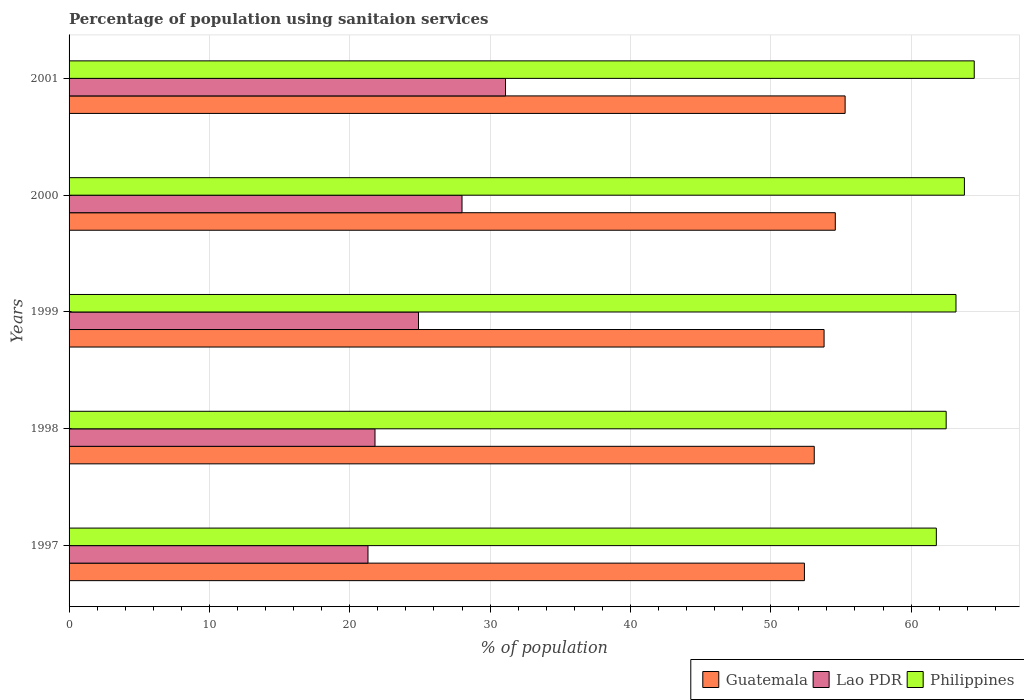How many different coloured bars are there?
Provide a short and direct response. 3. How many groups of bars are there?
Your answer should be very brief. 5. Are the number of bars on each tick of the Y-axis equal?
Provide a short and direct response. Yes. How many bars are there on the 1st tick from the top?
Make the answer very short. 3. How many bars are there on the 5th tick from the bottom?
Provide a succinct answer. 3. What is the percentage of population using sanitaion services in Guatemala in 2000?
Make the answer very short. 54.6. Across all years, what is the maximum percentage of population using sanitaion services in Philippines?
Your response must be concise. 64.5. Across all years, what is the minimum percentage of population using sanitaion services in Guatemala?
Ensure brevity in your answer.  52.4. In which year was the percentage of population using sanitaion services in Guatemala minimum?
Make the answer very short. 1997. What is the total percentage of population using sanitaion services in Lao PDR in the graph?
Give a very brief answer. 127.1. What is the difference between the percentage of population using sanitaion services in Lao PDR in 1999 and that in 2000?
Ensure brevity in your answer.  -3.1. What is the average percentage of population using sanitaion services in Guatemala per year?
Provide a succinct answer. 53.84. In the year 2001, what is the difference between the percentage of population using sanitaion services in Guatemala and percentage of population using sanitaion services in Lao PDR?
Your answer should be very brief. 24.2. What is the ratio of the percentage of population using sanitaion services in Philippines in 1997 to that in 2000?
Offer a terse response. 0.97. Is the difference between the percentage of population using sanitaion services in Guatemala in 1998 and 1999 greater than the difference between the percentage of population using sanitaion services in Lao PDR in 1998 and 1999?
Give a very brief answer. Yes. What is the difference between the highest and the second highest percentage of population using sanitaion services in Guatemala?
Provide a short and direct response. 0.7. What is the difference between the highest and the lowest percentage of population using sanitaion services in Lao PDR?
Your answer should be compact. 9.8. In how many years, is the percentage of population using sanitaion services in Philippines greater than the average percentage of population using sanitaion services in Philippines taken over all years?
Offer a terse response. 3. What does the 3rd bar from the top in 2001 represents?
Provide a short and direct response. Guatemala. What does the 2nd bar from the bottom in 2000 represents?
Offer a very short reply. Lao PDR. Is it the case that in every year, the sum of the percentage of population using sanitaion services in Guatemala and percentage of population using sanitaion services in Philippines is greater than the percentage of population using sanitaion services in Lao PDR?
Offer a terse response. Yes. Are the values on the major ticks of X-axis written in scientific E-notation?
Your answer should be compact. No. Does the graph contain grids?
Your answer should be very brief. Yes. How are the legend labels stacked?
Offer a terse response. Horizontal. What is the title of the graph?
Your answer should be very brief. Percentage of population using sanitaion services. What is the label or title of the X-axis?
Keep it short and to the point. % of population. What is the label or title of the Y-axis?
Make the answer very short. Years. What is the % of population of Guatemala in 1997?
Ensure brevity in your answer.  52.4. What is the % of population of Lao PDR in 1997?
Your answer should be compact. 21.3. What is the % of population of Philippines in 1997?
Your answer should be compact. 61.8. What is the % of population in Guatemala in 1998?
Offer a terse response. 53.1. What is the % of population in Lao PDR in 1998?
Your answer should be compact. 21.8. What is the % of population of Philippines in 1998?
Your answer should be very brief. 62.5. What is the % of population of Guatemala in 1999?
Provide a short and direct response. 53.8. What is the % of population of Lao PDR in 1999?
Your answer should be compact. 24.9. What is the % of population of Philippines in 1999?
Keep it short and to the point. 63.2. What is the % of population of Guatemala in 2000?
Provide a succinct answer. 54.6. What is the % of population of Lao PDR in 2000?
Offer a terse response. 28. What is the % of population of Philippines in 2000?
Offer a very short reply. 63.8. What is the % of population of Guatemala in 2001?
Your answer should be very brief. 55.3. What is the % of population of Lao PDR in 2001?
Provide a short and direct response. 31.1. What is the % of population in Philippines in 2001?
Ensure brevity in your answer.  64.5. Across all years, what is the maximum % of population of Guatemala?
Provide a succinct answer. 55.3. Across all years, what is the maximum % of population in Lao PDR?
Give a very brief answer. 31.1. Across all years, what is the maximum % of population of Philippines?
Ensure brevity in your answer.  64.5. Across all years, what is the minimum % of population in Guatemala?
Provide a succinct answer. 52.4. Across all years, what is the minimum % of population in Lao PDR?
Ensure brevity in your answer.  21.3. Across all years, what is the minimum % of population in Philippines?
Make the answer very short. 61.8. What is the total % of population of Guatemala in the graph?
Provide a succinct answer. 269.2. What is the total % of population in Lao PDR in the graph?
Offer a terse response. 127.1. What is the total % of population in Philippines in the graph?
Your answer should be compact. 315.8. What is the difference between the % of population of Lao PDR in 1997 and that in 1998?
Provide a succinct answer. -0.5. What is the difference between the % of population in Guatemala in 1997 and that in 1999?
Make the answer very short. -1.4. What is the difference between the % of population in Lao PDR in 1997 and that in 1999?
Give a very brief answer. -3.6. What is the difference between the % of population in Guatemala in 1997 and that in 2000?
Give a very brief answer. -2.2. What is the difference between the % of population of Lao PDR in 1997 and that in 2000?
Your response must be concise. -6.7. What is the difference between the % of population in Guatemala in 1997 and that in 2001?
Your response must be concise. -2.9. What is the difference between the % of population in Lao PDR in 1997 and that in 2001?
Provide a succinct answer. -9.8. What is the difference between the % of population in Philippines in 1997 and that in 2001?
Ensure brevity in your answer.  -2.7. What is the difference between the % of population of Lao PDR in 1998 and that in 1999?
Keep it short and to the point. -3.1. What is the difference between the % of population of Philippines in 1998 and that in 1999?
Your response must be concise. -0.7. What is the difference between the % of population in Guatemala in 1998 and that in 2000?
Your answer should be compact. -1.5. What is the difference between the % of population in Guatemala in 1998 and that in 2001?
Your answer should be compact. -2.2. What is the difference between the % of population of Lao PDR in 1998 and that in 2001?
Your answer should be very brief. -9.3. What is the difference between the % of population of Philippines in 1999 and that in 2001?
Your response must be concise. -1.3. What is the difference between the % of population of Guatemala in 2000 and that in 2001?
Your answer should be compact. -0.7. What is the difference between the % of population in Lao PDR in 2000 and that in 2001?
Ensure brevity in your answer.  -3.1. What is the difference between the % of population in Philippines in 2000 and that in 2001?
Ensure brevity in your answer.  -0.7. What is the difference between the % of population in Guatemala in 1997 and the % of population in Lao PDR in 1998?
Offer a terse response. 30.6. What is the difference between the % of population of Lao PDR in 1997 and the % of population of Philippines in 1998?
Keep it short and to the point. -41.2. What is the difference between the % of population in Guatemala in 1997 and the % of population in Lao PDR in 1999?
Your answer should be compact. 27.5. What is the difference between the % of population of Lao PDR in 1997 and the % of population of Philippines in 1999?
Give a very brief answer. -41.9. What is the difference between the % of population in Guatemala in 1997 and the % of population in Lao PDR in 2000?
Make the answer very short. 24.4. What is the difference between the % of population of Lao PDR in 1997 and the % of population of Philippines in 2000?
Make the answer very short. -42.5. What is the difference between the % of population of Guatemala in 1997 and the % of population of Lao PDR in 2001?
Provide a short and direct response. 21.3. What is the difference between the % of population of Lao PDR in 1997 and the % of population of Philippines in 2001?
Provide a short and direct response. -43.2. What is the difference between the % of population in Guatemala in 1998 and the % of population in Lao PDR in 1999?
Give a very brief answer. 28.2. What is the difference between the % of population in Guatemala in 1998 and the % of population in Philippines in 1999?
Your answer should be compact. -10.1. What is the difference between the % of population in Lao PDR in 1998 and the % of population in Philippines in 1999?
Ensure brevity in your answer.  -41.4. What is the difference between the % of population in Guatemala in 1998 and the % of population in Lao PDR in 2000?
Provide a succinct answer. 25.1. What is the difference between the % of population of Guatemala in 1998 and the % of population of Philippines in 2000?
Offer a very short reply. -10.7. What is the difference between the % of population in Lao PDR in 1998 and the % of population in Philippines in 2000?
Your response must be concise. -42. What is the difference between the % of population in Lao PDR in 1998 and the % of population in Philippines in 2001?
Keep it short and to the point. -42.7. What is the difference between the % of population in Guatemala in 1999 and the % of population in Lao PDR in 2000?
Offer a terse response. 25.8. What is the difference between the % of population in Guatemala in 1999 and the % of population in Philippines in 2000?
Your answer should be compact. -10. What is the difference between the % of population in Lao PDR in 1999 and the % of population in Philippines in 2000?
Keep it short and to the point. -38.9. What is the difference between the % of population of Guatemala in 1999 and the % of population of Lao PDR in 2001?
Offer a very short reply. 22.7. What is the difference between the % of population of Lao PDR in 1999 and the % of population of Philippines in 2001?
Provide a short and direct response. -39.6. What is the difference between the % of population in Lao PDR in 2000 and the % of population in Philippines in 2001?
Make the answer very short. -36.5. What is the average % of population in Guatemala per year?
Keep it short and to the point. 53.84. What is the average % of population of Lao PDR per year?
Ensure brevity in your answer.  25.42. What is the average % of population of Philippines per year?
Ensure brevity in your answer.  63.16. In the year 1997, what is the difference between the % of population in Guatemala and % of population in Lao PDR?
Give a very brief answer. 31.1. In the year 1997, what is the difference between the % of population in Lao PDR and % of population in Philippines?
Your answer should be compact. -40.5. In the year 1998, what is the difference between the % of population in Guatemala and % of population in Lao PDR?
Offer a terse response. 31.3. In the year 1998, what is the difference between the % of population of Guatemala and % of population of Philippines?
Your answer should be compact. -9.4. In the year 1998, what is the difference between the % of population in Lao PDR and % of population in Philippines?
Offer a terse response. -40.7. In the year 1999, what is the difference between the % of population in Guatemala and % of population in Lao PDR?
Make the answer very short. 28.9. In the year 1999, what is the difference between the % of population of Guatemala and % of population of Philippines?
Your answer should be very brief. -9.4. In the year 1999, what is the difference between the % of population of Lao PDR and % of population of Philippines?
Ensure brevity in your answer.  -38.3. In the year 2000, what is the difference between the % of population in Guatemala and % of population in Lao PDR?
Keep it short and to the point. 26.6. In the year 2000, what is the difference between the % of population in Guatemala and % of population in Philippines?
Provide a short and direct response. -9.2. In the year 2000, what is the difference between the % of population in Lao PDR and % of population in Philippines?
Your response must be concise. -35.8. In the year 2001, what is the difference between the % of population of Guatemala and % of population of Lao PDR?
Give a very brief answer. 24.2. In the year 2001, what is the difference between the % of population in Guatemala and % of population in Philippines?
Offer a very short reply. -9.2. In the year 2001, what is the difference between the % of population of Lao PDR and % of population of Philippines?
Give a very brief answer. -33.4. What is the ratio of the % of population of Guatemala in 1997 to that in 1998?
Your response must be concise. 0.99. What is the ratio of the % of population of Lao PDR in 1997 to that in 1998?
Offer a very short reply. 0.98. What is the ratio of the % of population of Philippines in 1997 to that in 1998?
Offer a terse response. 0.99. What is the ratio of the % of population in Guatemala in 1997 to that in 1999?
Offer a very short reply. 0.97. What is the ratio of the % of population of Lao PDR in 1997 to that in 1999?
Offer a terse response. 0.86. What is the ratio of the % of population of Philippines in 1997 to that in 1999?
Offer a very short reply. 0.98. What is the ratio of the % of population in Guatemala in 1997 to that in 2000?
Your answer should be compact. 0.96. What is the ratio of the % of population of Lao PDR in 1997 to that in 2000?
Your answer should be compact. 0.76. What is the ratio of the % of population of Philippines in 1997 to that in 2000?
Make the answer very short. 0.97. What is the ratio of the % of population of Guatemala in 1997 to that in 2001?
Your answer should be very brief. 0.95. What is the ratio of the % of population in Lao PDR in 1997 to that in 2001?
Your answer should be very brief. 0.68. What is the ratio of the % of population in Philippines in 1997 to that in 2001?
Offer a terse response. 0.96. What is the ratio of the % of population in Lao PDR in 1998 to that in 1999?
Offer a very short reply. 0.88. What is the ratio of the % of population in Philippines in 1998 to that in 1999?
Offer a very short reply. 0.99. What is the ratio of the % of population in Guatemala in 1998 to that in 2000?
Offer a terse response. 0.97. What is the ratio of the % of population in Lao PDR in 1998 to that in 2000?
Provide a short and direct response. 0.78. What is the ratio of the % of population of Philippines in 1998 to that in 2000?
Give a very brief answer. 0.98. What is the ratio of the % of population in Guatemala in 1998 to that in 2001?
Offer a terse response. 0.96. What is the ratio of the % of population in Lao PDR in 1998 to that in 2001?
Offer a very short reply. 0.7. What is the ratio of the % of population in Philippines in 1998 to that in 2001?
Offer a terse response. 0.97. What is the ratio of the % of population in Guatemala in 1999 to that in 2000?
Your answer should be compact. 0.99. What is the ratio of the % of population in Lao PDR in 1999 to that in 2000?
Provide a succinct answer. 0.89. What is the ratio of the % of population in Philippines in 1999 to that in 2000?
Ensure brevity in your answer.  0.99. What is the ratio of the % of population of Guatemala in 1999 to that in 2001?
Provide a short and direct response. 0.97. What is the ratio of the % of population in Lao PDR in 1999 to that in 2001?
Offer a very short reply. 0.8. What is the ratio of the % of population of Philippines in 1999 to that in 2001?
Your response must be concise. 0.98. What is the ratio of the % of population in Guatemala in 2000 to that in 2001?
Keep it short and to the point. 0.99. What is the ratio of the % of population in Lao PDR in 2000 to that in 2001?
Your answer should be compact. 0.9. What is the ratio of the % of population of Philippines in 2000 to that in 2001?
Your answer should be very brief. 0.99. What is the difference between the highest and the second highest % of population of Guatemala?
Your answer should be very brief. 0.7. What is the difference between the highest and the second highest % of population in Philippines?
Keep it short and to the point. 0.7. What is the difference between the highest and the lowest % of population of Guatemala?
Your answer should be very brief. 2.9. What is the difference between the highest and the lowest % of population of Lao PDR?
Your answer should be compact. 9.8. 